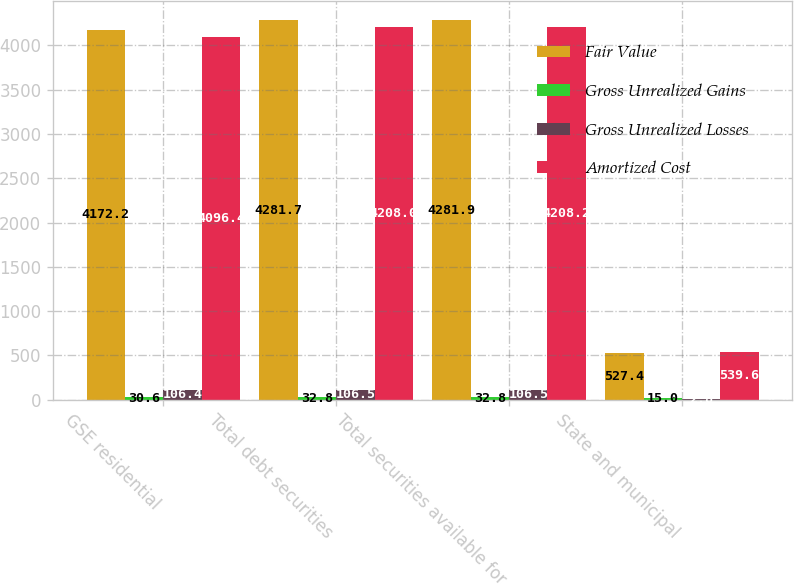<chart> <loc_0><loc_0><loc_500><loc_500><stacked_bar_chart><ecel><fcel>GSE residential<fcel>Total debt securities<fcel>Total securities available for<fcel>State and municipal<nl><fcel>Fair Value<fcel>4172.2<fcel>4281.7<fcel>4281.9<fcel>527.4<nl><fcel>Gross Unrealized Gains<fcel>30.6<fcel>32.8<fcel>32.8<fcel>15<nl><fcel>Gross Unrealized Losses<fcel>106.4<fcel>106.5<fcel>106.5<fcel>2.8<nl><fcel>Amortized Cost<fcel>4096.4<fcel>4208<fcel>4208.2<fcel>539.6<nl></chart> 